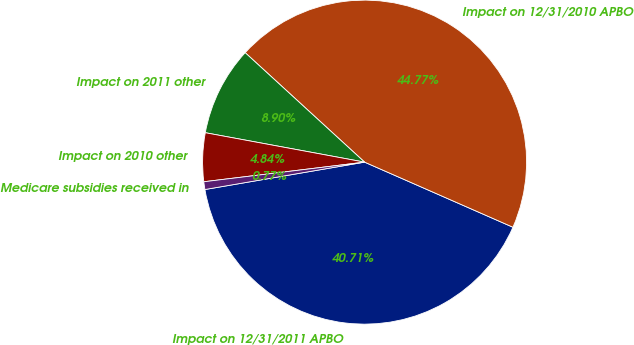<chart> <loc_0><loc_0><loc_500><loc_500><pie_chart><fcel>Impact on 12/31/2011 APBO<fcel>Impact on 12/31/2010 APBO<fcel>Impact on 2011 other<fcel>Impact on 2010 other<fcel>Medicare subsidies received in<nl><fcel>40.71%<fcel>44.77%<fcel>8.9%<fcel>4.84%<fcel>0.77%<nl></chart> 